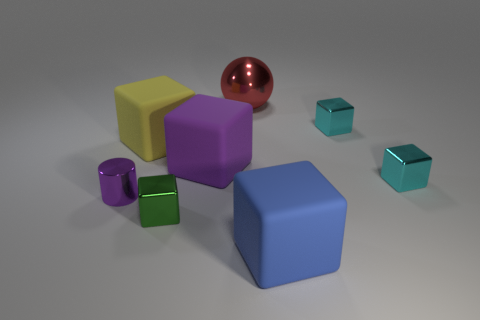What is the color of the small thing that is in front of the purple cube and right of the shiny sphere?
Provide a short and direct response. Cyan. What is the material of the blue cube?
Provide a succinct answer. Rubber. What is the shape of the big object right of the large red metallic ball?
Provide a succinct answer. Cube. There is a ball that is the same size as the yellow rubber block; what color is it?
Provide a short and direct response. Red. Is the material of the tiny cyan thing that is in front of the big purple matte object the same as the big blue cube?
Provide a succinct answer. No. There is a cube that is both in front of the tiny purple metal thing and left of the blue rubber block; what is its size?
Your answer should be very brief. Small. What size is the metallic block on the left side of the big red thing?
Your answer should be compact. Small. There is a matte object that is right of the red metallic sphere behind the tiny metal block left of the ball; what shape is it?
Provide a short and direct response. Cube. What number of other objects are the same shape as the big red shiny object?
Your response must be concise. 0. How many rubber objects are green cubes or purple things?
Provide a succinct answer. 1. 